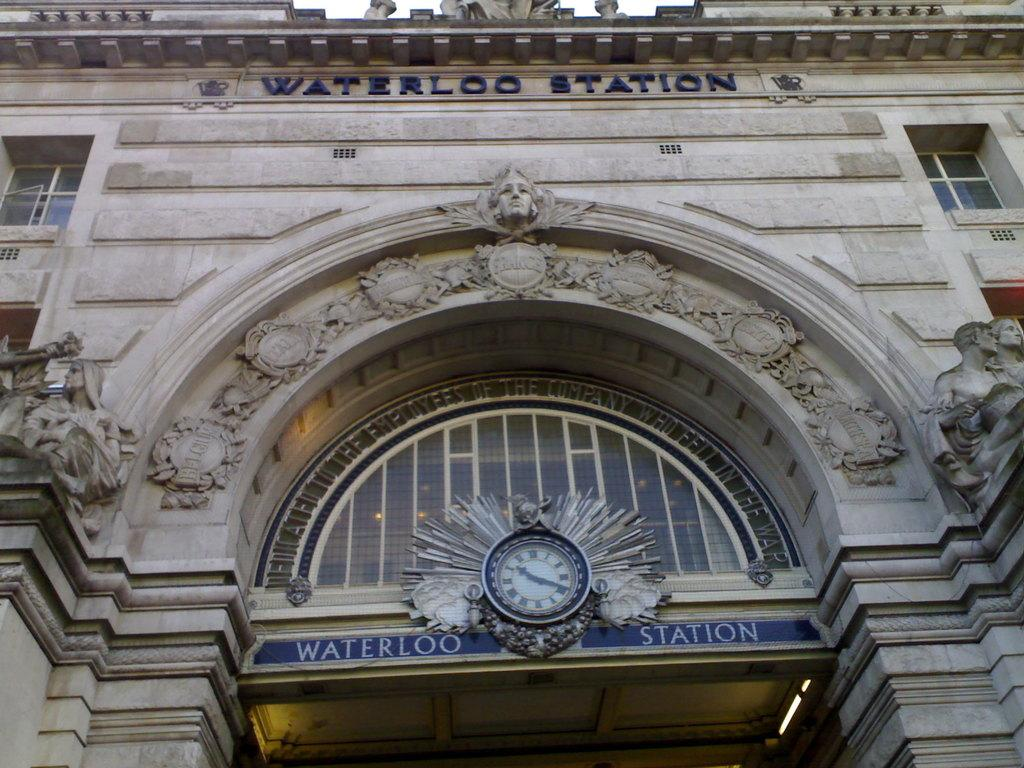<image>
Present a compact description of the photo's key features. The entrance to a train station called Waterloo Station. 